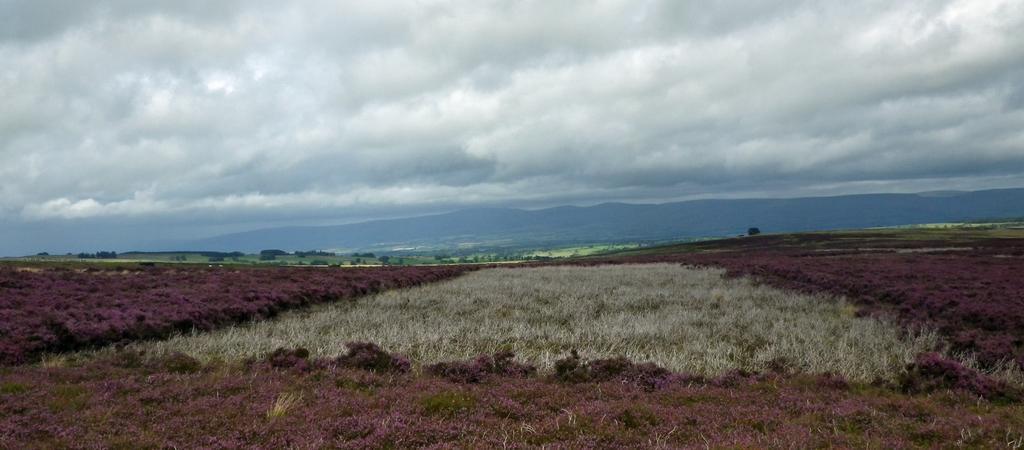Describe this image in one or two sentences. In this image we can see the grass, trees, hills, at the top we can see the sky with clouds. 